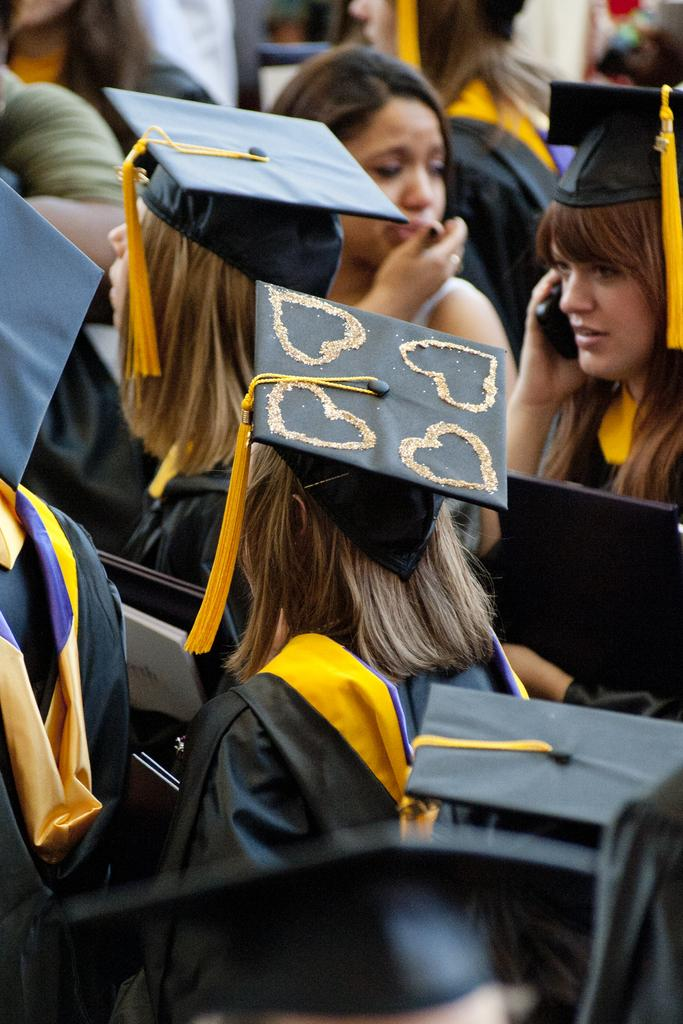How many people are in the image? There are persons in the image. What colors are featured in the dresses of the persons? The persons are wearing black and yellow colored dresses. What are the persons holding in the image? The persons are holding objects. Can you describe the background of the image? The background of the image is blurry. What type of bomb can be seen in the image? There is no bomb present in the image. How many bricks are visible in the image? There is no reference to bricks in the image, so it is not possible to determine how many are visible. 